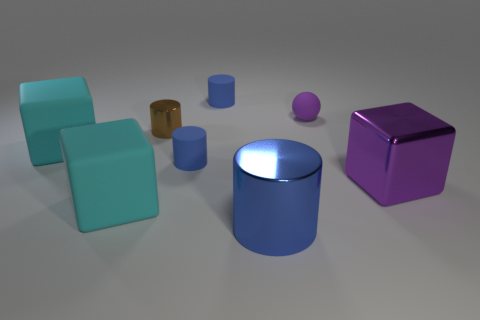What shape is the brown object that is the same material as the large cylinder?
Provide a short and direct response. Cylinder. Do the purple object behind the tiny brown metallic thing and the block that is on the right side of the blue shiny object have the same size?
Your response must be concise. No. What shape is the tiny object right of the big blue object?
Offer a terse response. Sphere. The tiny rubber ball is what color?
Make the answer very short. Purple. There is a purple rubber sphere; is it the same size as the metal thing that is behind the purple metallic block?
Make the answer very short. Yes. What number of matte objects are either purple things or large cyan cubes?
Provide a short and direct response. 3. Is there anything else that has the same material as the purple sphere?
Keep it short and to the point. Yes. There is a tiny rubber sphere; is its color the same as the big block in front of the purple metal block?
Make the answer very short. No. What shape is the purple metal thing?
Offer a very short reply. Cube. What size is the cyan matte cube that is in front of the large cube left of the cyan matte object in front of the large purple object?
Provide a succinct answer. Large. 